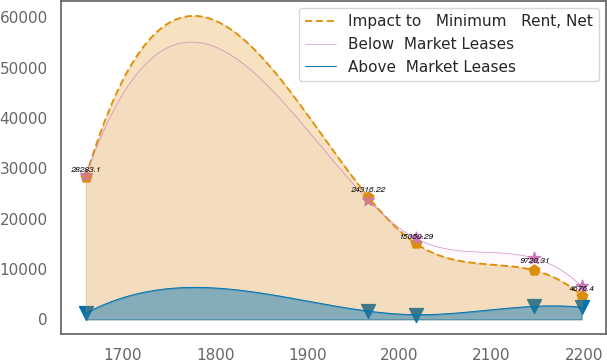Convert chart. <chart><loc_0><loc_0><loc_500><loc_500><line_chart><ecel><fcel>Impact to   Minimum   Rent, Net<fcel>Below  Market Leases<fcel>Above  Market Leases<nl><fcel>1659.62<fcel>28283.1<fcel>28558.2<fcel>1209.81<nl><fcel>1966.11<fcel>24316.2<fcel>23670.5<fcel>1624.16<nl><fcel>2017.76<fcel>15050.3<fcel>16064.7<fcel>907.99<nl><fcel>2146.11<fcel>9720.31<fcel>12146.9<fcel>2564.56<nl><fcel>2197.76<fcel>4676.4<fcel>6543.28<fcel>2385.05<nl></chart> 